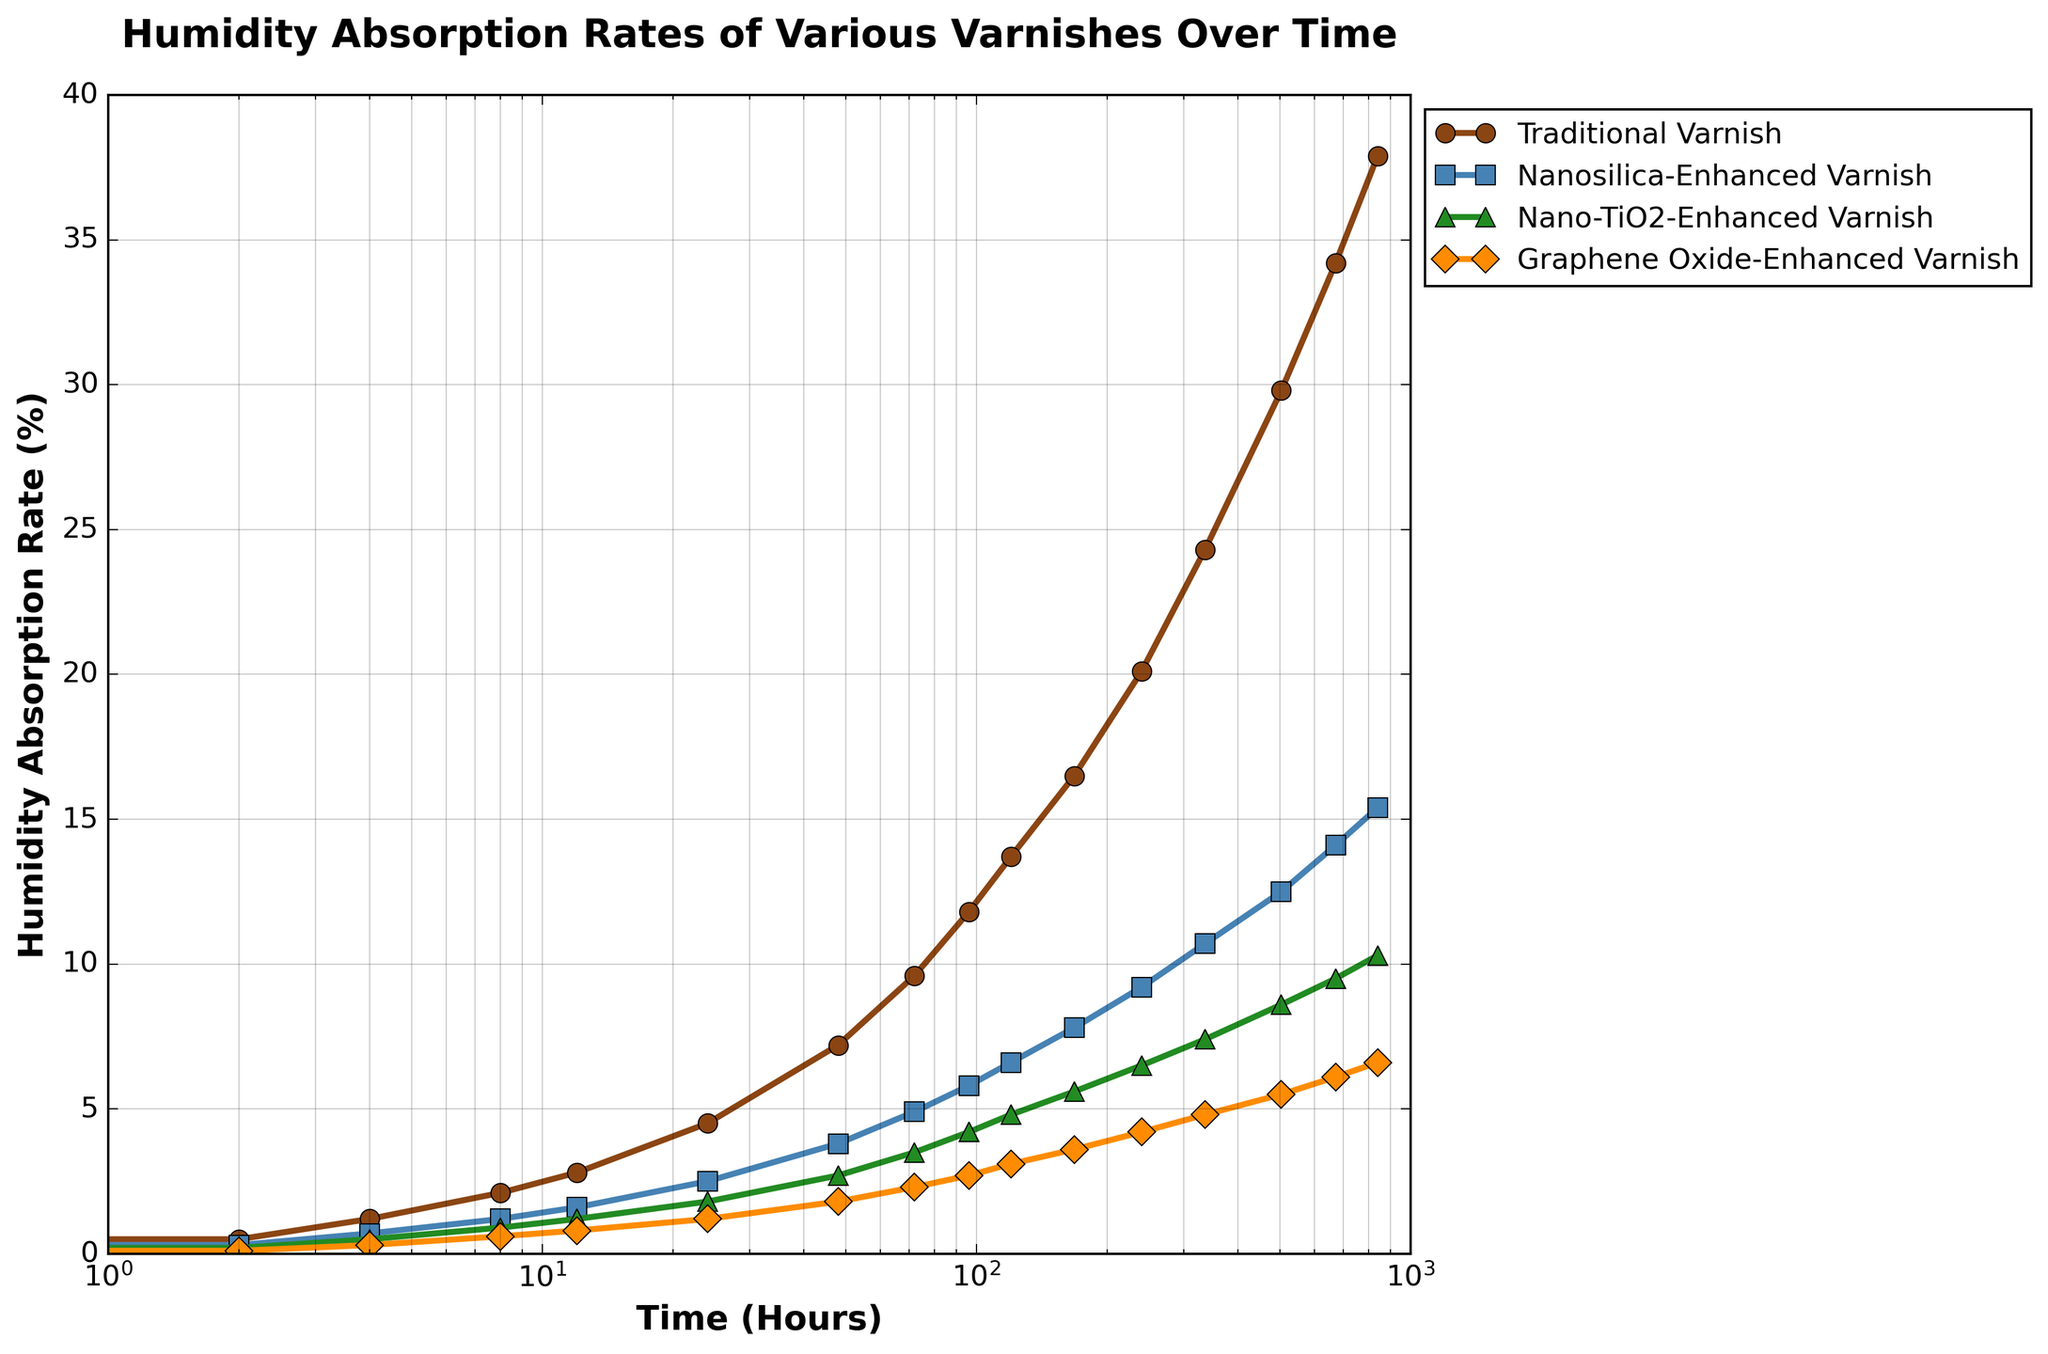Which varnish shows the lowest humidity absorption rate throughout the observed period? By examining the lines on the plot, we can see that the Graphene Oxide-Enhanced Varnish consistently has the lowest curve among all varnishes.
Answer: Graphene Oxide-Enhanced Varnish At the 12-hour mark, how much greater is the humidity absorption rate of the Traditional Varnish compared to the Nano-TiO2-Enhanced Varnish? At 12 hours, the Traditional Varnish has an absorption rate of 2.8%, while the Nano-TiO2-Enhanced Varnish has an absorption rate of 1.2%. The difference is 2.8 - 1.2 = 1.6%.
Answer: 1.6% Which varnish experiences the steepest increase in humidity absorption from 0 to 2 hours? To find this, look for the steepest initial slope. The Traditional Varnish increases from 0% to 0.5%, which is the largest increase among all varnishes in the first 2 hours.
Answer: Traditional Varnish How does the absorption rate of Nanosilica-Enhanced Varnish at the 168-hour mark compare to the Traditional Varnish at the same time? At 168 hours, the Nanosilica-Enhanced Varnish has an absorption rate of 7.8%, while the Traditional Varnish has a rate of 16.5%. Hence, the Traditional Varnish's rate is much higher.
Answer: Traditional Varnish's rate is higher By how much does the humidity absorption rate of Nano-TiO2-Enhanced Varnish change from the 72-hour mark to the 336-hour mark? At 72 hours, the Nano-TiO2 rate is 3.5%, and it increases to 7.4% at 336 hours. The change is 7.4 - 3.5 = 3.9%.
Answer: 3.9% What's the average humidity absorption rate of the Graphene Oxide-Enhanced Varnish over the first 24 hours? The Graphene Oxide-Enhanced Varnish rates at 0, 2, 4, 8, 12, and 24 hours are 0%, 0.1%, 0.3%, 0.6%, 0.8%, and 1.2%, respectively. The average is (0 + 0.1 + 0.3 + 0.6 + 0.8 + 1.2)/6 = 0.5%.
Answer: 0.5% Which varnish's absorption rate exceeds 10% first? By checking the timeline on the plot, Traditional Varnish crosses the 10% mark first, around 96 hours.
Answer: Traditional Varnish How do the absorption rates of Nanosilica-Enhanced Varnish and Nano-TiO2-Enhanced Varnish at 504 hours compare? At 504 hours, the Nanosilica-Enhanced Varnish has a rate of 12.5%, while the Nano-TiO2-Enhanced Varnish has a rate of 8.6%. Therefore, the rate for the Nanosilica-Enhanced Varnish is higher.
Answer: Nanosilica-Enhanced Varnish's rate is higher 